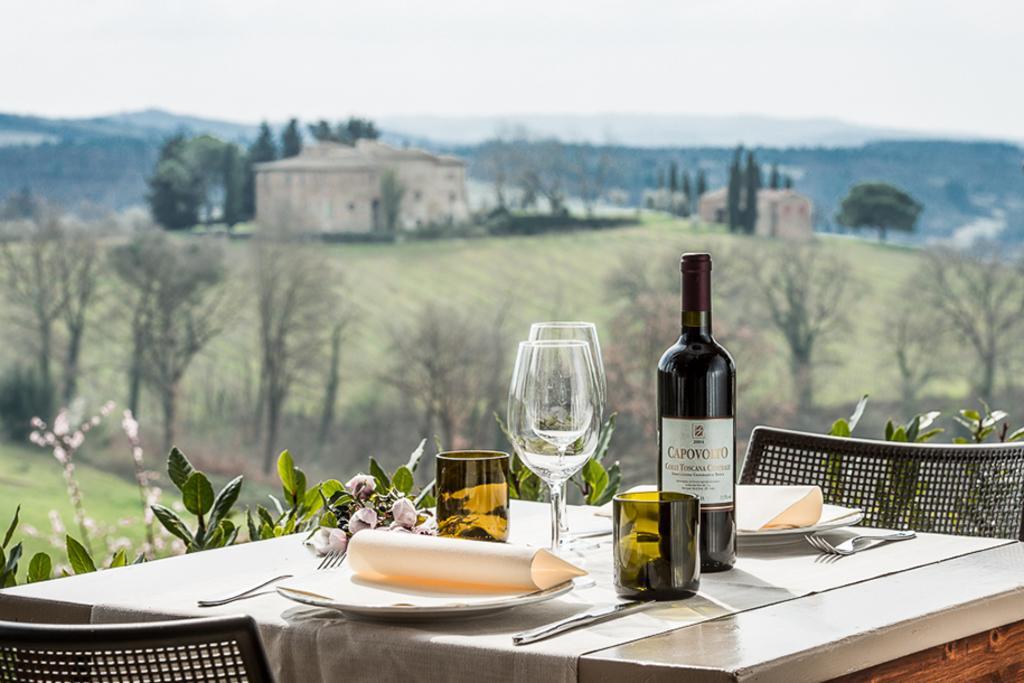In one or two sentences, can you explain what this image depicts? At the top we can see sky, Hills trees , houses and grass. Here we can see bare trees. There is bottle, glass, mugs, plate, spoons, forks and a white cloth and also flowers on the table. These are chairs. 